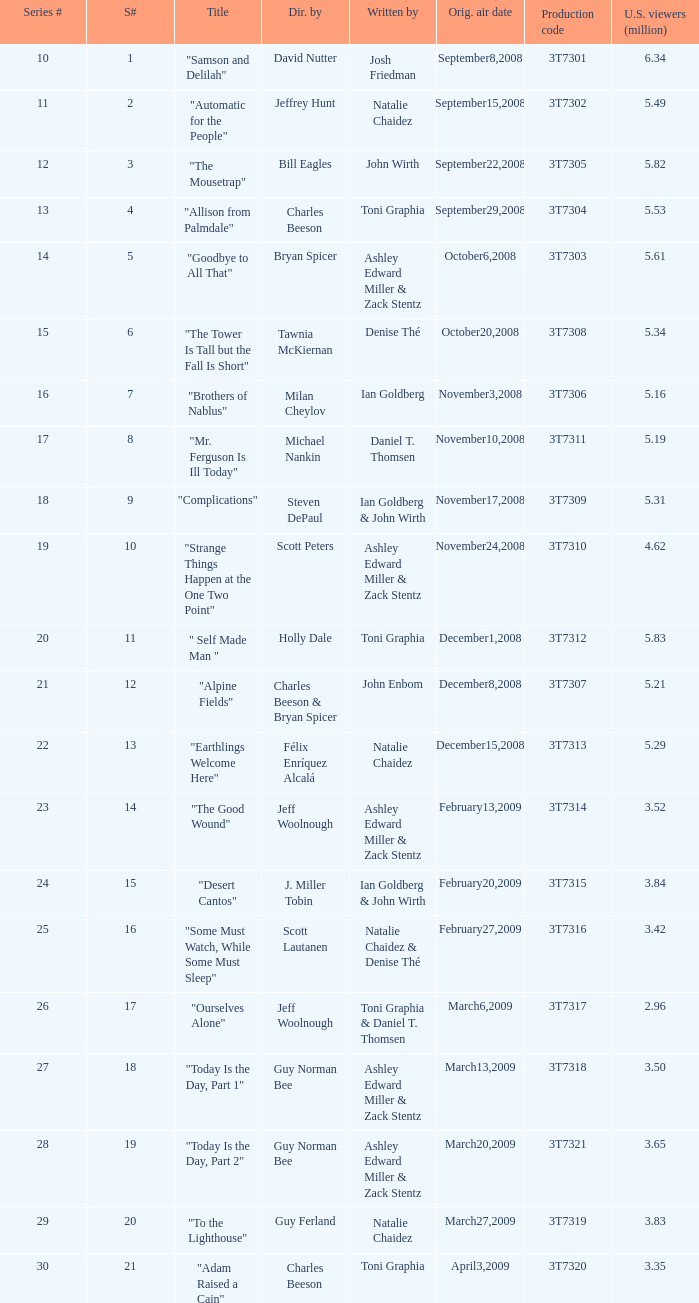Which episode number was directed by Bill Eagles? 12.0. 